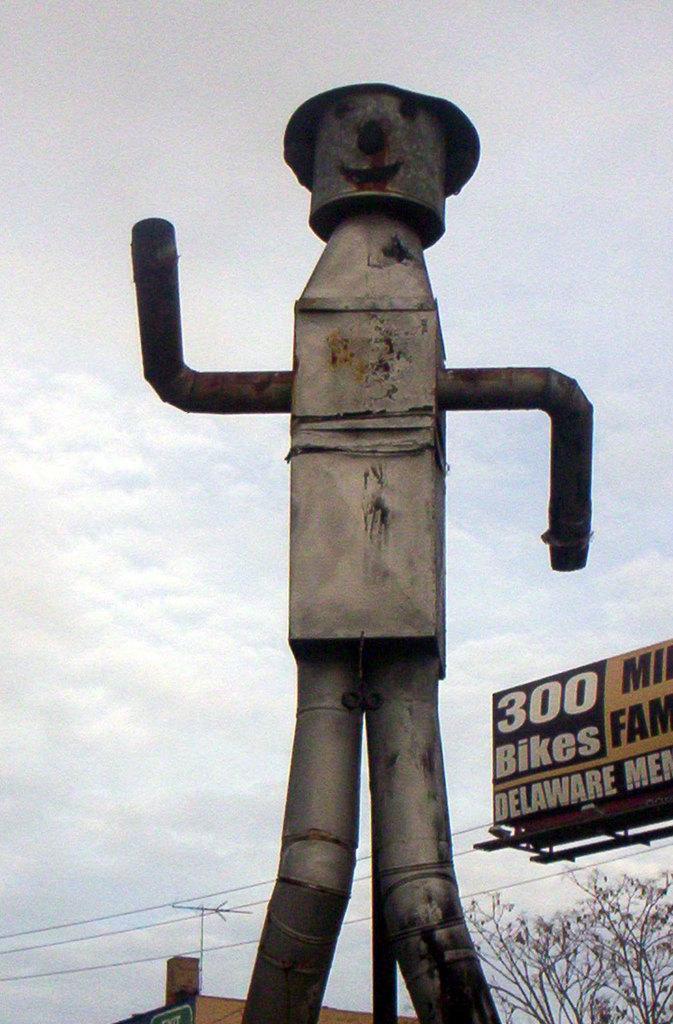Describe this image in one or two sentences. There is a pole with pipes. On the right side there is a name board. Also there are trees. In the back there is sky. There are wires. 